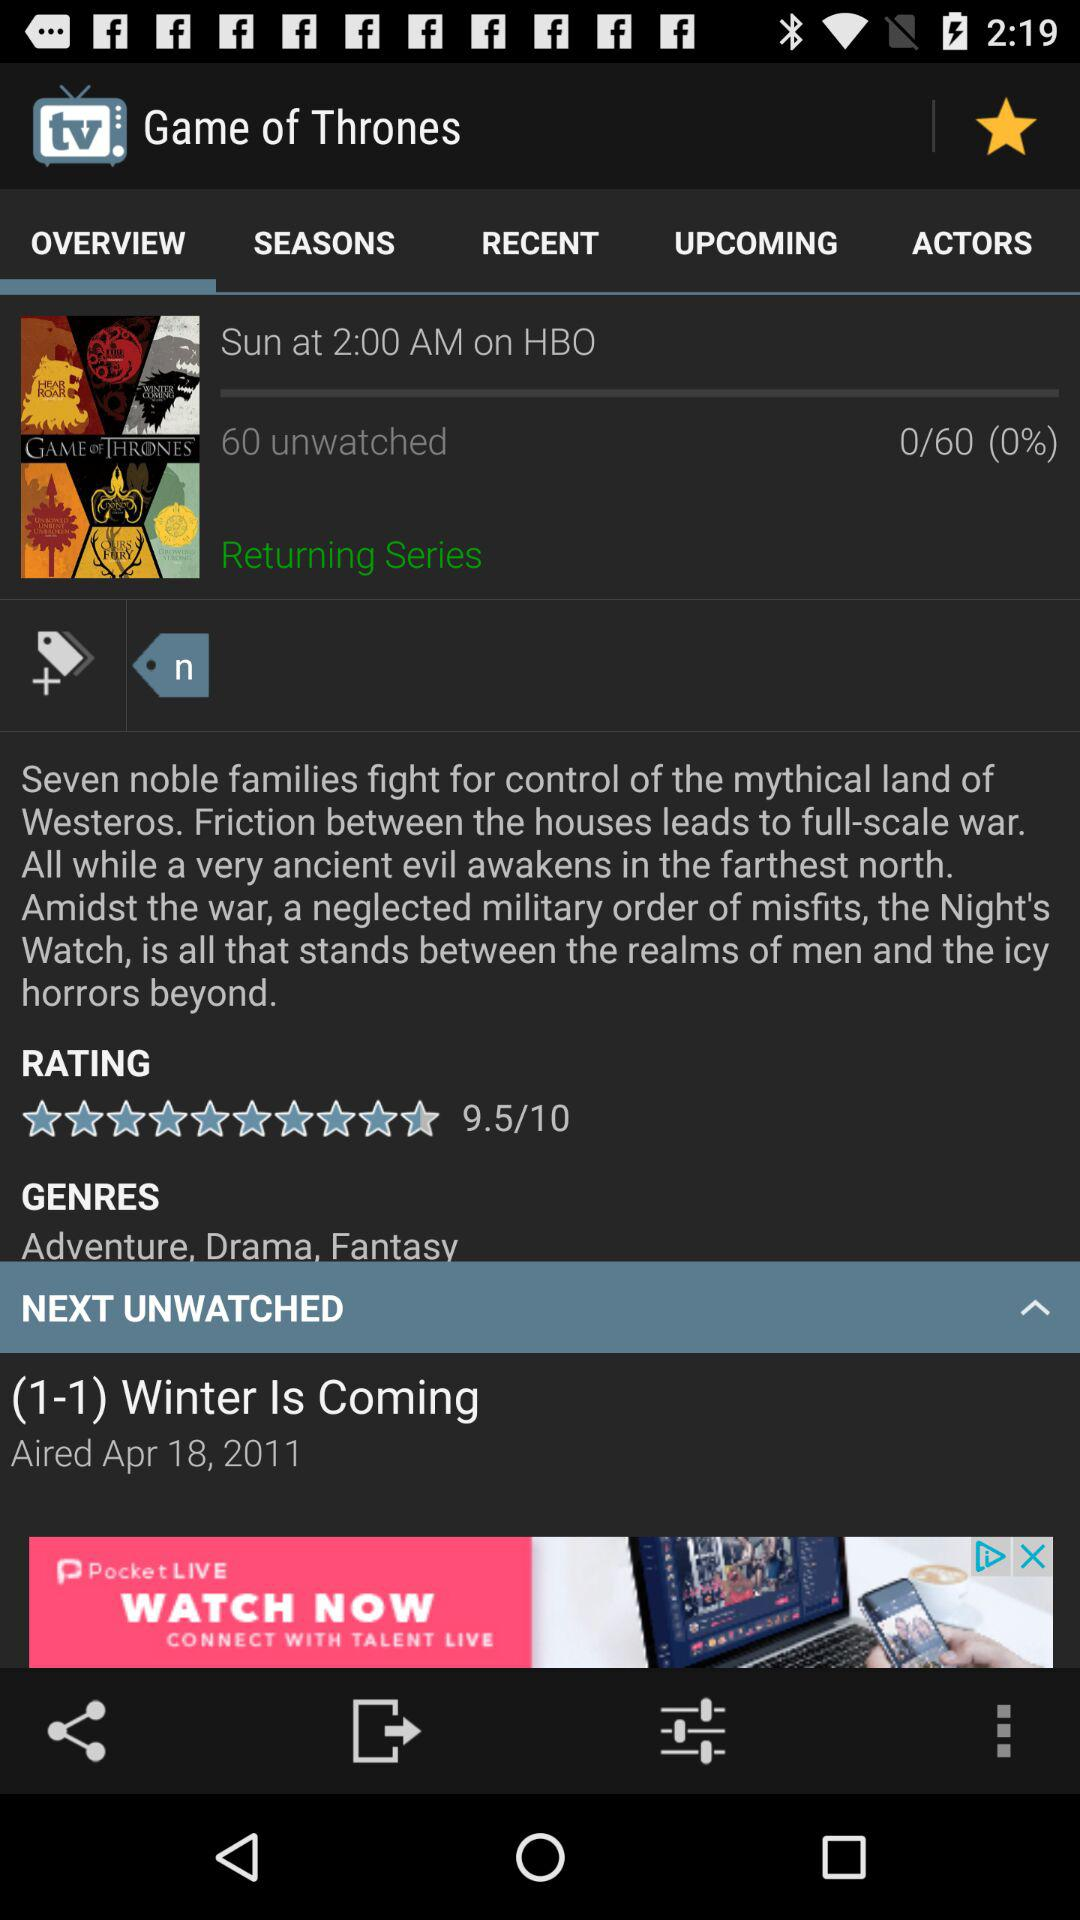What are the genres of the series "Game of Thrones"? The genres are adventure, drama and fantasy. 